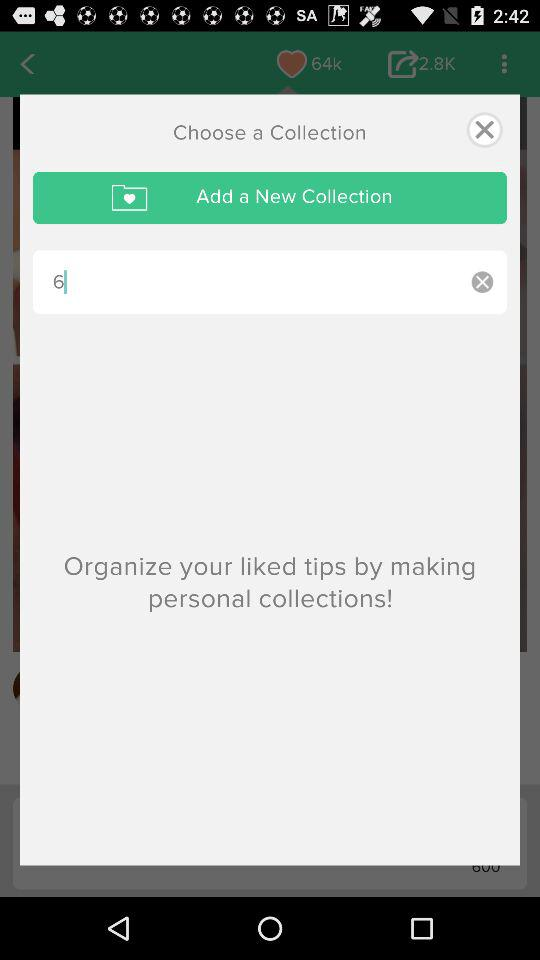How many likes are there? There are 64 k likes. 